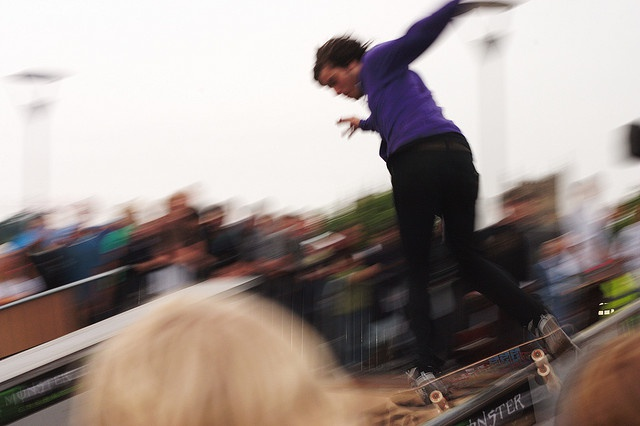Describe the objects in this image and their specific colors. I can see people in white, black, navy, lightgray, and maroon tones, people in white, tan, and gray tones, people in white, maroon, brown, and gray tones, skateboard in white, black, maroon, and gray tones, and people in white, black, maroon, brown, and gray tones in this image. 